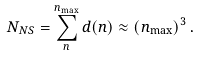Convert formula to latex. <formula><loc_0><loc_0><loc_500><loc_500>N _ { N S } = \sum _ { n } ^ { n _ { \max } } d ( n ) \approx \left ( n _ { \max } \right ) ^ { 3 } .</formula> 